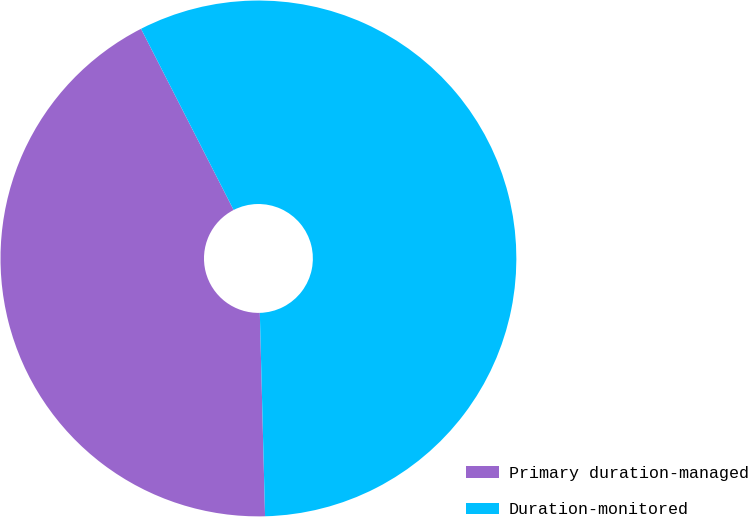<chart> <loc_0><loc_0><loc_500><loc_500><pie_chart><fcel>Primary duration-managed<fcel>Duration-monitored<nl><fcel>42.89%<fcel>57.11%<nl></chart> 